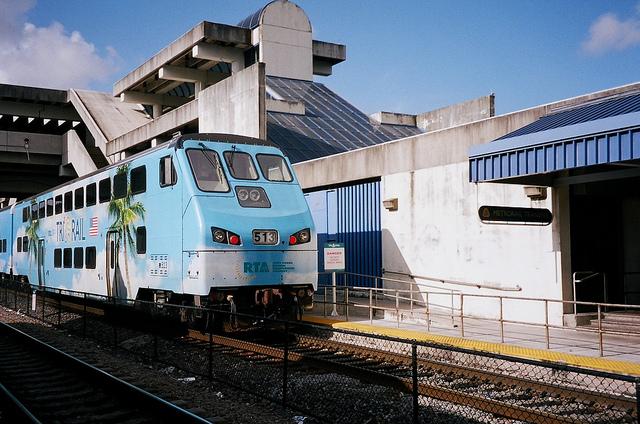What color is the first car?
Give a very brief answer. Blue. Is the train in motion or static?
Keep it brief. Static. Is it sunny outside?
Answer briefly. Yes. What number does this train have on it?
Give a very brief answer. 513. Is the train on solid ground?
Answer briefly. Yes. What color is the train engine?
Short answer required. Blue. Do you see high mountains?
Answer briefly. No. What color is the train?
Concise answer only. Blue. Which train station is this?
Short answer required. Rta. How many blue trains are there?
Concise answer only. 1. 